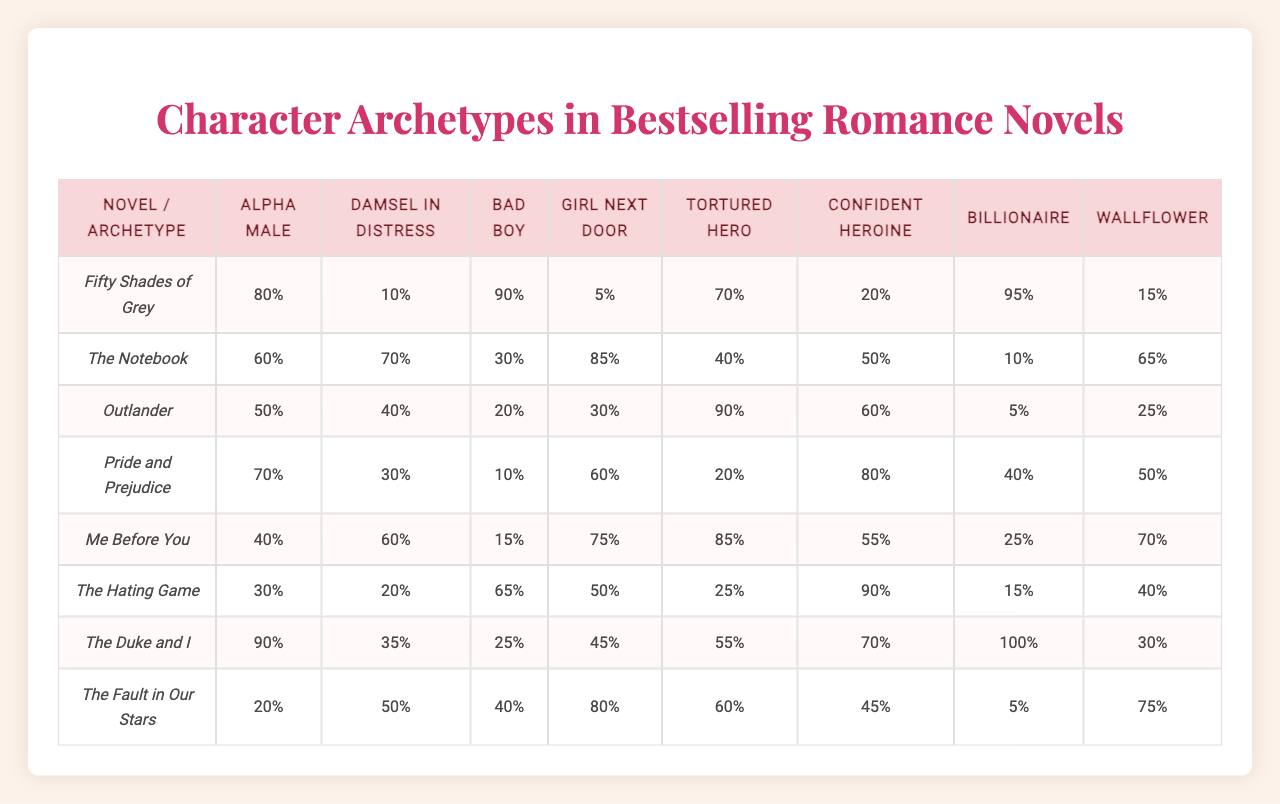What is the most frequently represented archetype in "Fifty Shades of Grey"? In the table, the frequencies for each archetype in "Fifty Shades of Grey" are listed. The highest value corresponds to the "Billionaire" archetype at 95%.
Answer: Billionaire How many archetypes are represented in "The Notebook"? The table indicates that "The Notebook" includes values for eight different archetypes. Therefore, all listed archetypes are represented within this novel.
Answer: 8 Which archetype appears the least in "Me Before You"? By looking at the table, the frequency values for each archetype in "Me Before You" show that the "Billionaire" archetype appears the least, with a frequency of 25%.
Answer: Billionaire What is the average frequency of the "Damsel in Distress" archetype across all novels? To find the average frequency, sum the frequencies of the "Damsel in Distress" archetype (10 + 70 + 40 + 30 + 60 + 20 + 35 + 50 = 315) and divide by the number of novels (8). The average frequency is 315/8 = 39.375%.
Answer: 39.375% Is the "Alpha Male" archetype more common in "The Hating Game" than in "The Fault in Our Stars"? The frequency of "Alpha Male" in "The Hating Game" is 30% and in "The Fault in Our Stars" is 20%. Since 30% is greater than 20%, the statement is true.
Answer: Yes Which archetype has the highest presence in "The Duke and I"? Checking the frequencies for "The Duke and I", the "Alpha Male" archetype has the highest frequency at 90%.
Answer: Alpha Male What is the difference in frequency for the "Girl Next Door" archetype between "Outlander" and "Me Before You"? The frequency for the "Girl Next Door" archetype is 30% in "Outlander" and 75% in "Me Before You". The difference is 75% - 30% = 45%.
Answer: 45% In which novel does the "Bad Boy" archetype have the highest representation? By examining the frequencies for the "Bad Boy" archetype across all novels, it's clear that "Fifty Shades of Grey" features this archetype the most with 90%.
Answer: Fifty Shades of Grey What percentage of novels feature the "Wallflower" archetype with a frequency of 50% or higher? The table shows that "The Notebook", "The Hating Game", and "The Duke and I" have a frequency of 50% or higher for the "Wallflower" archetype, amounting to 3 out of 8 novels (3/8) = 37.5%.
Answer: 37.5% Is it true that the "Tortured Hero" archetype is more frequent in "Pride and Prejudice" than in "The Fault in Our Stars"? The frequency of the "Tortured Hero" archetype is 20% in "Pride and Prejudice" and 70% in "The Fault in Our Stars". Since 20% is not greater than 70%, the statement is false.
Answer: No 